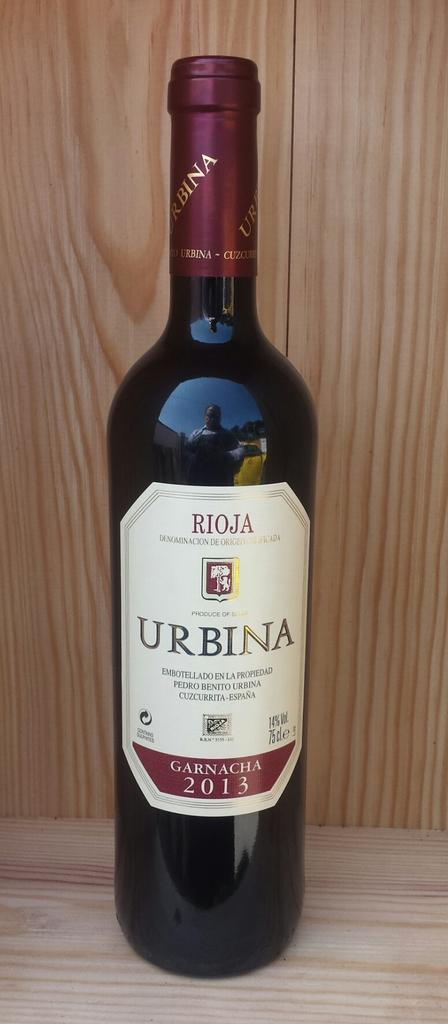<image>
Present a compact description of the photo's key features. A bottle of Urbina Rioja from 2013 is sitting on a wooden shelf. 